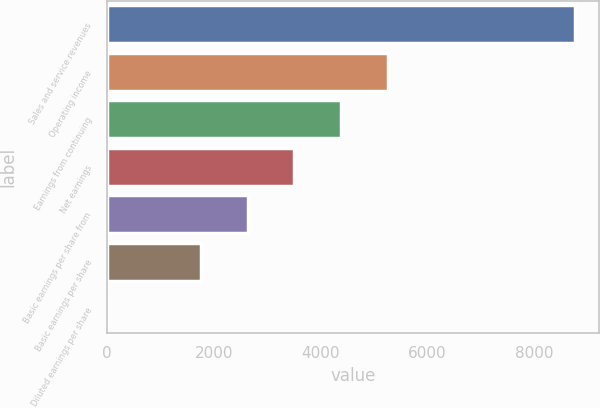Convert chart to OTSL. <chart><loc_0><loc_0><loc_500><loc_500><bar_chart><fcel>Sales and service revenues<fcel>Operating income<fcel>Earnings from continuing<fcel>Net earnings<fcel>Basic earnings per share from<fcel>Basic earnings per share<fcel>Diluted earnings per share<nl><fcel>8765<fcel>5259.53<fcel>4383.16<fcel>3506.79<fcel>2630.42<fcel>1754.05<fcel>1.31<nl></chart> 